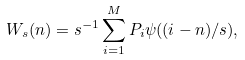Convert formula to latex. <formula><loc_0><loc_0><loc_500><loc_500>W _ { s } ( n ) = s ^ { - 1 } \sum _ { i = 1 } ^ { M } P _ { i } \psi ( ( i - n ) / s ) ,</formula> 